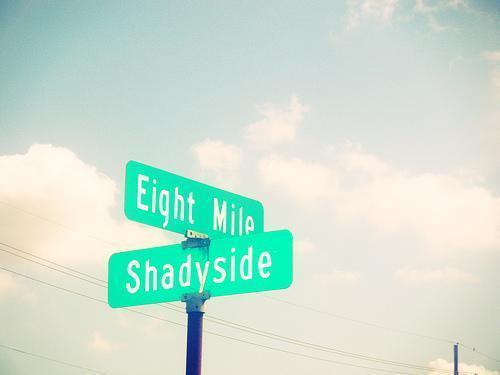How many letters are there in the bottom street sign?
Give a very brief answer. 9. 